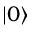Convert formula to latex. <formula><loc_0><loc_0><loc_500><loc_500>| 0 \rangle</formula> 